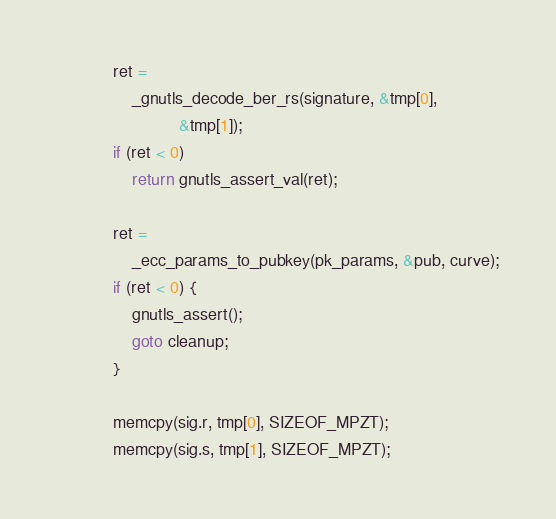<code> <loc_0><loc_0><loc_500><loc_500><_C_>			ret =
			    _gnutls_decode_ber_rs(signature, &tmp[0],
						  &tmp[1]);
			if (ret < 0)
				return gnutls_assert_val(ret);

			ret =
			    _ecc_params_to_pubkey(pk_params, &pub, curve);
			if (ret < 0) {
				gnutls_assert();
				goto cleanup;
			}

			memcpy(sig.r, tmp[0], SIZEOF_MPZT);
			memcpy(sig.s, tmp[1], SIZEOF_MPZT);
</code> 